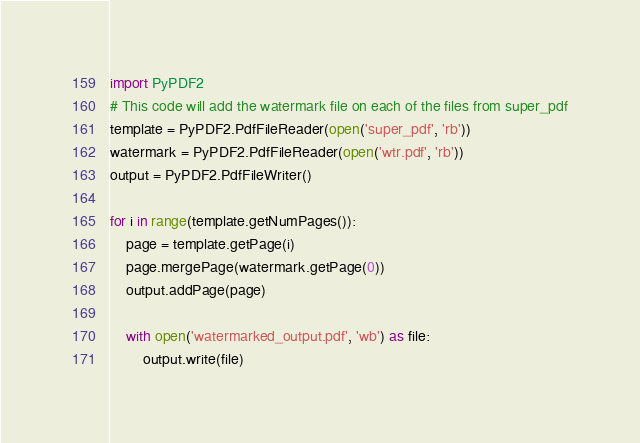Convert code to text. <code><loc_0><loc_0><loc_500><loc_500><_Python_>import PyPDF2
# This code will add the watermark file on each of the files from super_pdf
template = PyPDF2.PdfFileReader(open('super_pdf', 'rb'))
watermark = PyPDF2.PdfFileReader(open('wtr.pdf', 'rb'))
output = PyPDF2.PdfFileWriter()

for i in range(template.getNumPages()):
    page = template.getPage(i)
    page.mergePage(watermark.getPage(0))
    output.addPage(page)

    with open('watermarked_output.pdf', 'wb') as file:
        output.write(file)</code> 